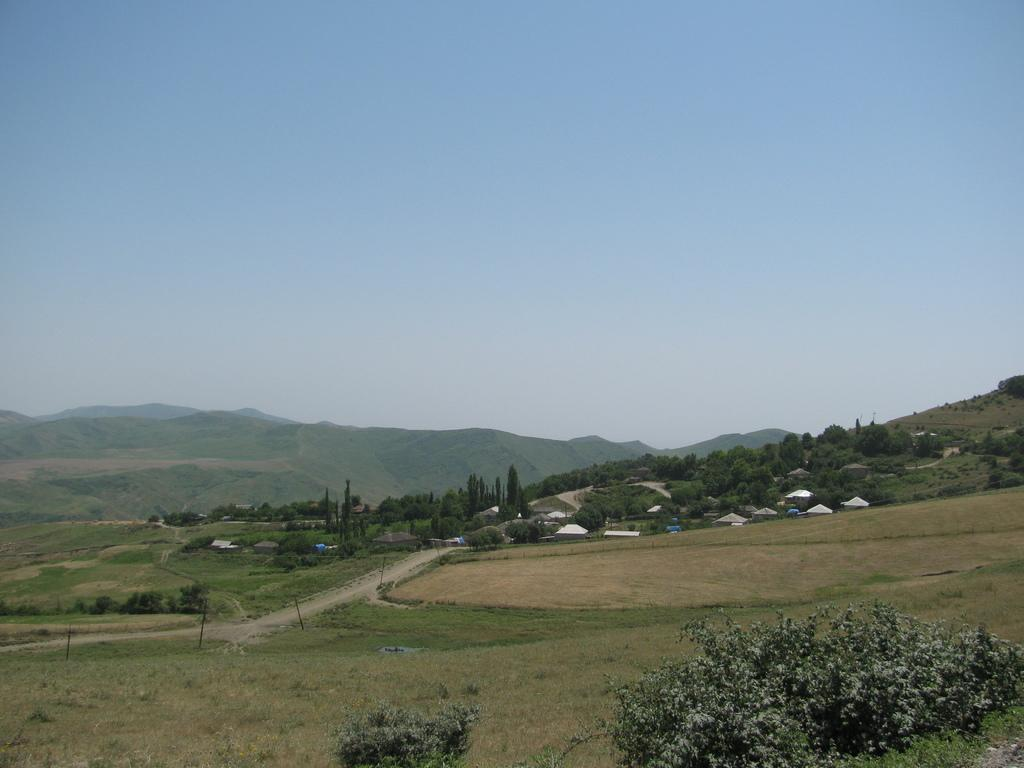What type of natural landscape is visible in the image? There are mountains in the image. What type of terrain is present at the base of the mountains? There is ground with grass in the image. What type of man-made structures can be seen in the image? There are buildings in the image. What type of vegetation is present in the image? There are trees in the image. Can you tell me how many wrens are perched on the buildings in the image? There are no wrens present in the image. Is there a harbor visible in the image? There is no harbor visible in the image. 